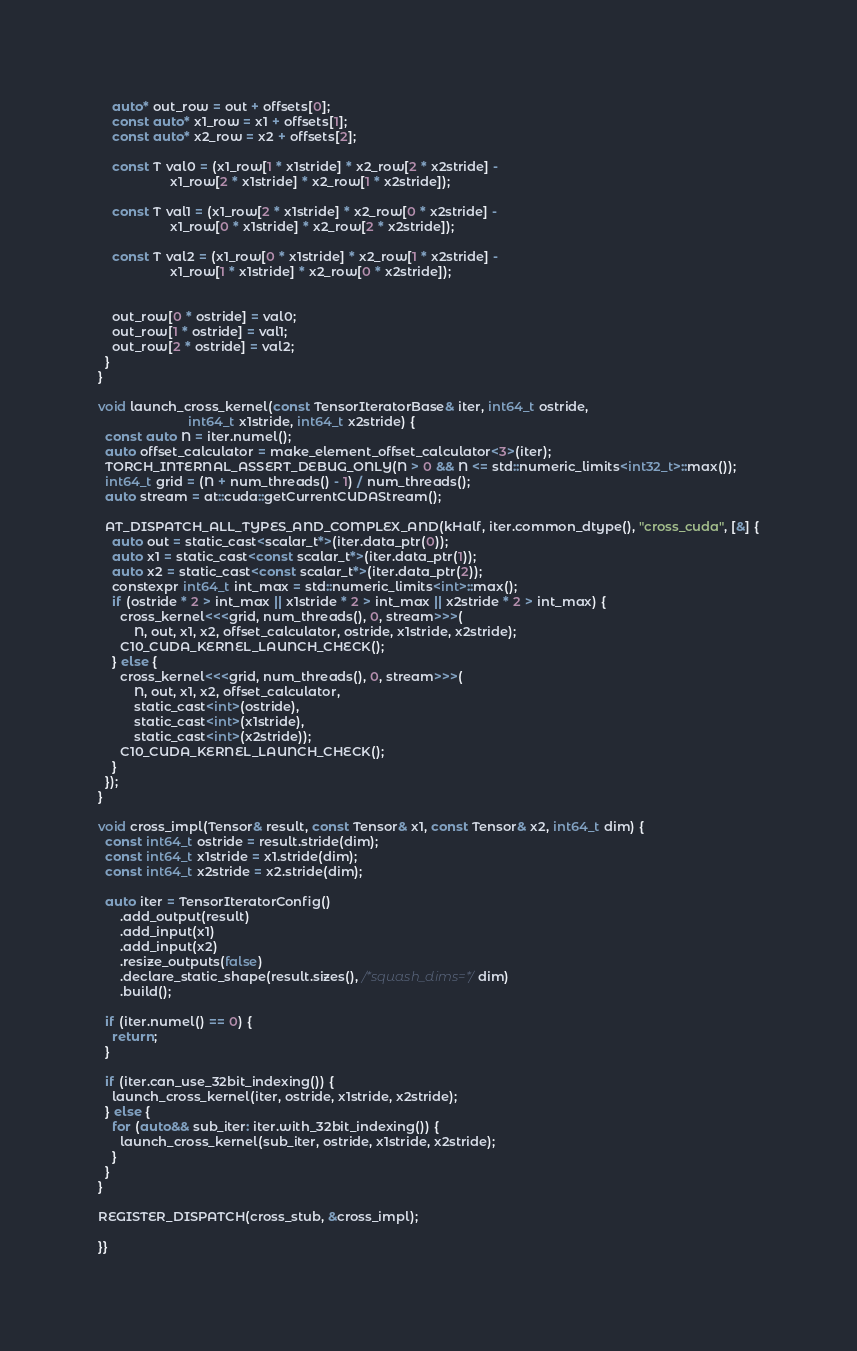Convert code to text. <code><loc_0><loc_0><loc_500><loc_500><_Cuda_>    auto* out_row = out + offsets[0];
    const auto* x1_row = x1 + offsets[1];
    const auto* x2_row = x2 + offsets[2];

    const T val0 = (x1_row[1 * x1stride] * x2_row[2 * x2stride] -
                    x1_row[2 * x1stride] * x2_row[1 * x2stride]);

    const T val1 = (x1_row[2 * x1stride] * x2_row[0 * x2stride] -
                    x1_row[0 * x1stride] * x2_row[2 * x2stride]);

    const T val2 = (x1_row[0 * x1stride] * x2_row[1 * x2stride] -
                    x1_row[1 * x1stride] * x2_row[0 * x2stride]);


    out_row[0 * ostride] = val0;
    out_row[1 * ostride] = val1;
    out_row[2 * ostride] = val2;
  }
}

void launch_cross_kernel(const TensorIteratorBase& iter, int64_t ostride,
                         int64_t x1stride, int64_t x2stride) {
  const auto N = iter.numel();
  auto offset_calculator = make_element_offset_calculator<3>(iter);
  TORCH_INTERNAL_ASSERT_DEBUG_ONLY(N > 0 && N <= std::numeric_limits<int32_t>::max());
  int64_t grid = (N + num_threads() - 1) / num_threads();
  auto stream = at::cuda::getCurrentCUDAStream();

  AT_DISPATCH_ALL_TYPES_AND_COMPLEX_AND(kHalf, iter.common_dtype(), "cross_cuda", [&] {
    auto out = static_cast<scalar_t*>(iter.data_ptr(0));
    auto x1 = static_cast<const scalar_t*>(iter.data_ptr(1));
    auto x2 = static_cast<const scalar_t*>(iter.data_ptr(2));
    constexpr int64_t int_max = std::numeric_limits<int>::max();
    if (ostride * 2 > int_max || x1stride * 2 > int_max || x2stride * 2 > int_max) {
      cross_kernel<<<grid, num_threads(), 0, stream>>>(
          N, out, x1, x2, offset_calculator, ostride, x1stride, x2stride);
      C10_CUDA_KERNEL_LAUNCH_CHECK();
    } else {
      cross_kernel<<<grid, num_threads(), 0, stream>>>(
          N, out, x1, x2, offset_calculator,
          static_cast<int>(ostride),
          static_cast<int>(x1stride),
          static_cast<int>(x2stride));
      C10_CUDA_KERNEL_LAUNCH_CHECK();
    }
  });
}

void cross_impl(Tensor& result, const Tensor& x1, const Tensor& x2, int64_t dim) {
  const int64_t ostride = result.stride(dim);
  const int64_t x1stride = x1.stride(dim);
  const int64_t x2stride = x2.stride(dim);

  auto iter = TensorIteratorConfig()
      .add_output(result)
      .add_input(x1)
      .add_input(x2)
      .resize_outputs(false)
      .declare_static_shape(result.sizes(), /*squash_dims=*/dim)
      .build();

  if (iter.numel() == 0) {
    return;
  }

  if (iter.can_use_32bit_indexing()) {
    launch_cross_kernel(iter, ostride, x1stride, x2stride);
  } else {
    for (auto&& sub_iter: iter.with_32bit_indexing()) {
      launch_cross_kernel(sub_iter, ostride, x1stride, x2stride);
    }
  }
}

REGISTER_DISPATCH(cross_stub, &cross_impl);

}}
</code> 